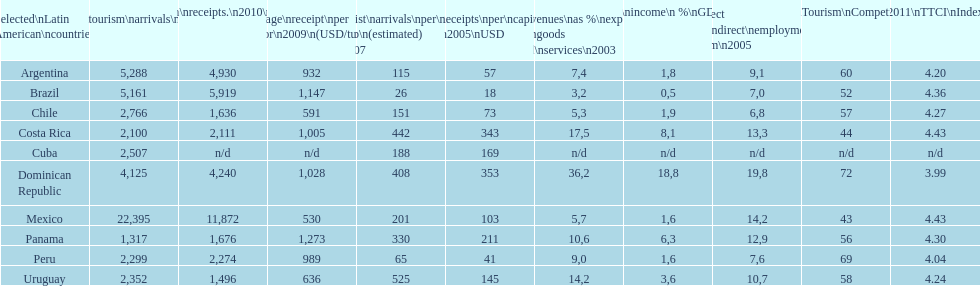What was the count of international travelers (x1000) visiting mexico in 2010? 22,395. 